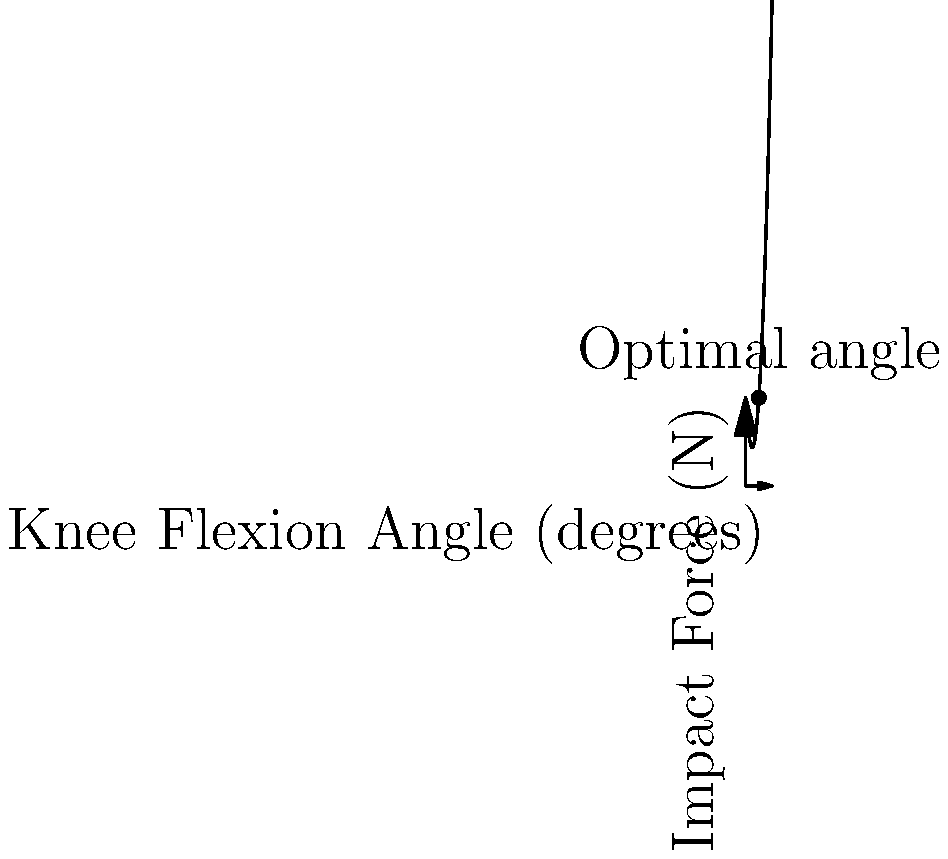Based on the graph showing the relationship between knee flexion angle and impact force during landing, what is the optimal knee flexion angle to minimize impact force? To find the optimal knee flexion angle that minimizes impact force, we need to follow these steps:

1. Observe the graph: The curve represents the relationship between knee flexion angle (x-axis) and impact force (y-axis).

2. Identify the lowest point: The optimal angle corresponds to the lowest point on the curve, which represents the minimum impact force.

3. Locate the minimum: From the graph, we can see that the lowest point of the curve occurs at approximately 30 degrees of knee flexion.

4. Understand the physics: This optimal angle allows for:
   a) Sufficient bend in the knees to absorb the landing impact
   b) Proper distribution of forces across the leg muscles and joints
   c) Balanced position for maintaining stability

5. Consider the implications: Landing with this optimal knee flexion angle helps to:
   a) Reduce the risk of knee injuries
   b) Improve overall landing mechanics
   c) Enhance performance by allowing for quicker transitions to subsequent movements

The graph clearly shows that a knee flexion angle of about 30 degrees results in the lowest impact force, making it the optimal angle for landing to minimize injury risk.
Answer: 30 degrees 